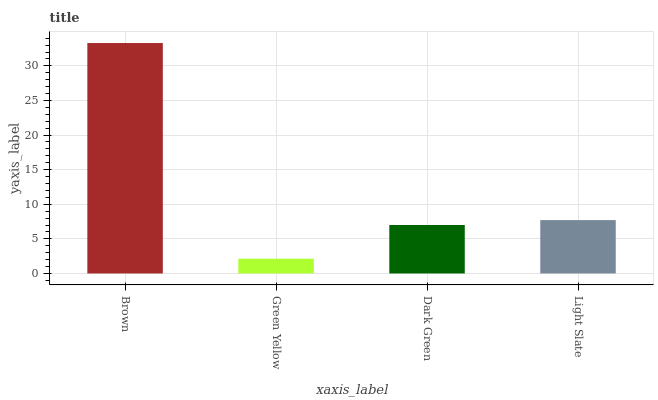Is Green Yellow the minimum?
Answer yes or no. Yes. Is Brown the maximum?
Answer yes or no. Yes. Is Dark Green the minimum?
Answer yes or no. No. Is Dark Green the maximum?
Answer yes or no. No. Is Dark Green greater than Green Yellow?
Answer yes or no. Yes. Is Green Yellow less than Dark Green?
Answer yes or no. Yes. Is Green Yellow greater than Dark Green?
Answer yes or no. No. Is Dark Green less than Green Yellow?
Answer yes or no. No. Is Light Slate the high median?
Answer yes or no. Yes. Is Dark Green the low median?
Answer yes or no. Yes. Is Dark Green the high median?
Answer yes or no. No. Is Light Slate the low median?
Answer yes or no. No. 